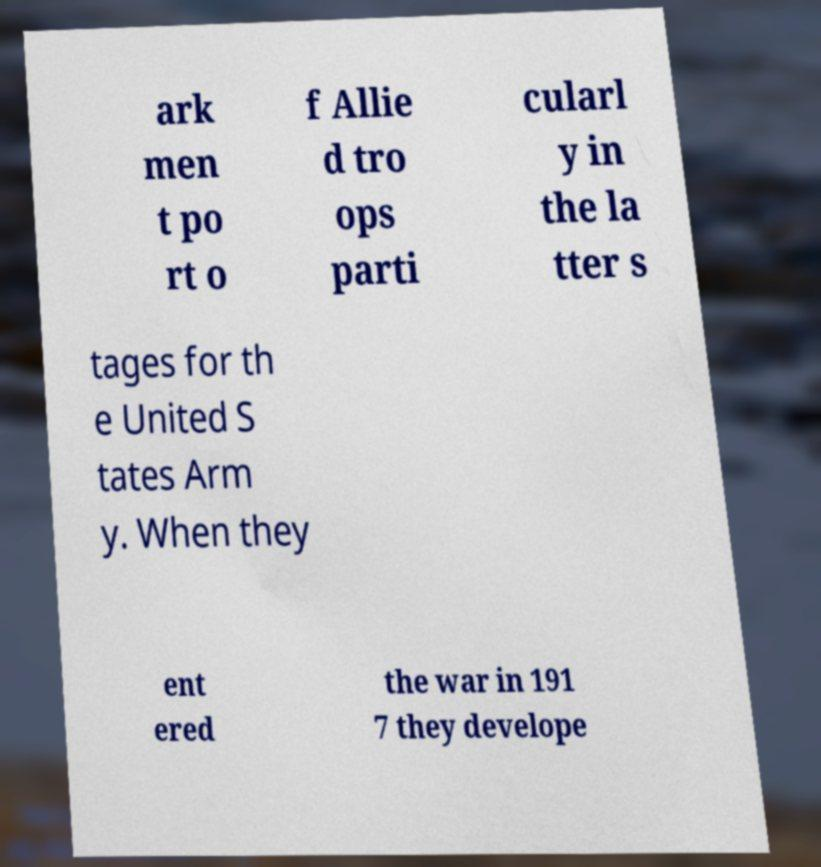Could you assist in decoding the text presented in this image and type it out clearly? ark men t po rt o f Allie d tro ops parti cularl y in the la tter s tages for th e United S tates Arm y. When they ent ered the war in 191 7 they develope 